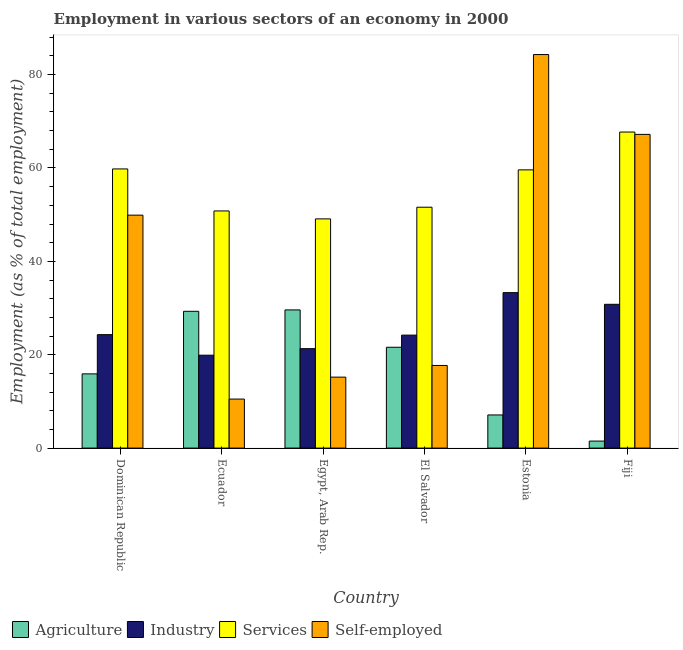How many groups of bars are there?
Ensure brevity in your answer.  6. Are the number of bars per tick equal to the number of legend labels?
Your answer should be very brief. Yes. How many bars are there on the 3rd tick from the left?
Offer a terse response. 4. What is the label of the 5th group of bars from the left?
Ensure brevity in your answer.  Estonia. What is the percentage of workers in industry in Ecuador?
Provide a succinct answer. 19.9. Across all countries, what is the maximum percentage of self employed workers?
Offer a very short reply. 84.3. Across all countries, what is the minimum percentage of workers in industry?
Give a very brief answer. 19.9. In which country was the percentage of self employed workers maximum?
Offer a terse response. Estonia. In which country was the percentage of workers in industry minimum?
Keep it short and to the point. Ecuador. What is the total percentage of workers in agriculture in the graph?
Provide a short and direct response. 105. What is the difference between the percentage of workers in industry in Egypt, Arab Rep. and that in El Salvador?
Make the answer very short. -2.9. What is the difference between the percentage of self employed workers in Fiji and the percentage of workers in industry in El Salvador?
Offer a very short reply. 43. What is the average percentage of self employed workers per country?
Give a very brief answer. 40.8. What is the difference between the percentage of workers in agriculture and percentage of self employed workers in El Salvador?
Ensure brevity in your answer.  3.9. In how many countries, is the percentage of self employed workers greater than 20 %?
Your response must be concise. 3. What is the ratio of the percentage of workers in agriculture in El Salvador to that in Estonia?
Offer a very short reply. 3.04. Is the difference between the percentage of workers in industry in Estonia and Fiji greater than the difference between the percentage of self employed workers in Estonia and Fiji?
Keep it short and to the point. No. What is the difference between the highest and the second highest percentage of workers in services?
Provide a succinct answer. 7.9. What is the difference between the highest and the lowest percentage of self employed workers?
Your response must be concise. 73.8. In how many countries, is the percentage of workers in services greater than the average percentage of workers in services taken over all countries?
Provide a succinct answer. 3. Is it the case that in every country, the sum of the percentage of self employed workers and percentage of workers in services is greater than the sum of percentage of workers in agriculture and percentage of workers in industry?
Provide a short and direct response. No. What does the 3rd bar from the left in Fiji represents?
Your answer should be very brief. Services. What does the 4th bar from the right in El Salvador represents?
Offer a terse response. Agriculture. How many countries are there in the graph?
Offer a very short reply. 6. Are the values on the major ticks of Y-axis written in scientific E-notation?
Your response must be concise. No. Does the graph contain any zero values?
Your response must be concise. No. Does the graph contain grids?
Offer a terse response. No. How are the legend labels stacked?
Your answer should be compact. Horizontal. What is the title of the graph?
Provide a succinct answer. Employment in various sectors of an economy in 2000. What is the label or title of the Y-axis?
Offer a terse response. Employment (as % of total employment). What is the Employment (as % of total employment) of Agriculture in Dominican Republic?
Offer a very short reply. 15.9. What is the Employment (as % of total employment) in Industry in Dominican Republic?
Your response must be concise. 24.3. What is the Employment (as % of total employment) in Services in Dominican Republic?
Offer a very short reply. 59.8. What is the Employment (as % of total employment) in Self-employed in Dominican Republic?
Provide a short and direct response. 49.9. What is the Employment (as % of total employment) of Agriculture in Ecuador?
Give a very brief answer. 29.3. What is the Employment (as % of total employment) of Industry in Ecuador?
Offer a terse response. 19.9. What is the Employment (as % of total employment) in Services in Ecuador?
Provide a succinct answer. 50.8. What is the Employment (as % of total employment) in Self-employed in Ecuador?
Offer a very short reply. 10.5. What is the Employment (as % of total employment) in Agriculture in Egypt, Arab Rep.?
Keep it short and to the point. 29.6. What is the Employment (as % of total employment) in Industry in Egypt, Arab Rep.?
Ensure brevity in your answer.  21.3. What is the Employment (as % of total employment) of Services in Egypt, Arab Rep.?
Offer a terse response. 49.1. What is the Employment (as % of total employment) of Self-employed in Egypt, Arab Rep.?
Keep it short and to the point. 15.2. What is the Employment (as % of total employment) in Agriculture in El Salvador?
Make the answer very short. 21.6. What is the Employment (as % of total employment) in Industry in El Salvador?
Your answer should be very brief. 24.2. What is the Employment (as % of total employment) in Services in El Salvador?
Your response must be concise. 51.6. What is the Employment (as % of total employment) of Self-employed in El Salvador?
Ensure brevity in your answer.  17.7. What is the Employment (as % of total employment) in Agriculture in Estonia?
Your response must be concise. 7.1. What is the Employment (as % of total employment) in Industry in Estonia?
Your response must be concise. 33.3. What is the Employment (as % of total employment) of Services in Estonia?
Your answer should be compact. 59.6. What is the Employment (as % of total employment) of Self-employed in Estonia?
Offer a terse response. 84.3. What is the Employment (as % of total employment) in Agriculture in Fiji?
Ensure brevity in your answer.  1.5. What is the Employment (as % of total employment) in Industry in Fiji?
Offer a very short reply. 30.8. What is the Employment (as % of total employment) in Services in Fiji?
Offer a very short reply. 67.7. What is the Employment (as % of total employment) of Self-employed in Fiji?
Keep it short and to the point. 67.2. Across all countries, what is the maximum Employment (as % of total employment) of Agriculture?
Your answer should be very brief. 29.6. Across all countries, what is the maximum Employment (as % of total employment) in Industry?
Your answer should be compact. 33.3. Across all countries, what is the maximum Employment (as % of total employment) of Services?
Your answer should be compact. 67.7. Across all countries, what is the maximum Employment (as % of total employment) in Self-employed?
Your answer should be very brief. 84.3. Across all countries, what is the minimum Employment (as % of total employment) of Industry?
Make the answer very short. 19.9. Across all countries, what is the minimum Employment (as % of total employment) of Services?
Your answer should be compact. 49.1. What is the total Employment (as % of total employment) of Agriculture in the graph?
Keep it short and to the point. 105. What is the total Employment (as % of total employment) in Industry in the graph?
Provide a short and direct response. 153.8. What is the total Employment (as % of total employment) in Services in the graph?
Your answer should be very brief. 338.6. What is the total Employment (as % of total employment) in Self-employed in the graph?
Ensure brevity in your answer.  244.8. What is the difference between the Employment (as % of total employment) of Agriculture in Dominican Republic and that in Ecuador?
Make the answer very short. -13.4. What is the difference between the Employment (as % of total employment) in Self-employed in Dominican Republic and that in Ecuador?
Offer a very short reply. 39.4. What is the difference between the Employment (as % of total employment) in Agriculture in Dominican Republic and that in Egypt, Arab Rep.?
Keep it short and to the point. -13.7. What is the difference between the Employment (as % of total employment) in Self-employed in Dominican Republic and that in Egypt, Arab Rep.?
Ensure brevity in your answer.  34.7. What is the difference between the Employment (as % of total employment) in Agriculture in Dominican Republic and that in El Salvador?
Your response must be concise. -5.7. What is the difference between the Employment (as % of total employment) in Industry in Dominican Republic and that in El Salvador?
Provide a succinct answer. 0.1. What is the difference between the Employment (as % of total employment) in Self-employed in Dominican Republic and that in El Salvador?
Your response must be concise. 32.2. What is the difference between the Employment (as % of total employment) of Agriculture in Dominican Republic and that in Estonia?
Provide a short and direct response. 8.8. What is the difference between the Employment (as % of total employment) of Self-employed in Dominican Republic and that in Estonia?
Your response must be concise. -34.4. What is the difference between the Employment (as % of total employment) in Agriculture in Dominican Republic and that in Fiji?
Provide a succinct answer. 14.4. What is the difference between the Employment (as % of total employment) of Self-employed in Dominican Republic and that in Fiji?
Your answer should be compact. -17.3. What is the difference between the Employment (as % of total employment) in Agriculture in Ecuador and that in Egypt, Arab Rep.?
Your response must be concise. -0.3. What is the difference between the Employment (as % of total employment) in Industry in Ecuador and that in Egypt, Arab Rep.?
Your response must be concise. -1.4. What is the difference between the Employment (as % of total employment) in Services in Ecuador and that in Egypt, Arab Rep.?
Ensure brevity in your answer.  1.7. What is the difference between the Employment (as % of total employment) of Self-employed in Ecuador and that in Egypt, Arab Rep.?
Ensure brevity in your answer.  -4.7. What is the difference between the Employment (as % of total employment) of Agriculture in Ecuador and that in El Salvador?
Your response must be concise. 7.7. What is the difference between the Employment (as % of total employment) in Industry in Ecuador and that in El Salvador?
Your response must be concise. -4.3. What is the difference between the Employment (as % of total employment) of Services in Ecuador and that in El Salvador?
Make the answer very short. -0.8. What is the difference between the Employment (as % of total employment) in Agriculture in Ecuador and that in Estonia?
Make the answer very short. 22.2. What is the difference between the Employment (as % of total employment) of Services in Ecuador and that in Estonia?
Provide a succinct answer. -8.8. What is the difference between the Employment (as % of total employment) in Self-employed in Ecuador and that in Estonia?
Offer a very short reply. -73.8. What is the difference between the Employment (as % of total employment) of Agriculture in Ecuador and that in Fiji?
Offer a very short reply. 27.8. What is the difference between the Employment (as % of total employment) in Industry in Ecuador and that in Fiji?
Offer a terse response. -10.9. What is the difference between the Employment (as % of total employment) in Services in Ecuador and that in Fiji?
Make the answer very short. -16.9. What is the difference between the Employment (as % of total employment) of Self-employed in Ecuador and that in Fiji?
Your answer should be compact. -56.7. What is the difference between the Employment (as % of total employment) in Agriculture in Egypt, Arab Rep. and that in El Salvador?
Your response must be concise. 8. What is the difference between the Employment (as % of total employment) of Industry in Egypt, Arab Rep. and that in El Salvador?
Provide a succinct answer. -2.9. What is the difference between the Employment (as % of total employment) in Self-employed in Egypt, Arab Rep. and that in Estonia?
Your answer should be very brief. -69.1. What is the difference between the Employment (as % of total employment) in Agriculture in Egypt, Arab Rep. and that in Fiji?
Your answer should be very brief. 28.1. What is the difference between the Employment (as % of total employment) of Industry in Egypt, Arab Rep. and that in Fiji?
Give a very brief answer. -9.5. What is the difference between the Employment (as % of total employment) in Services in Egypt, Arab Rep. and that in Fiji?
Offer a very short reply. -18.6. What is the difference between the Employment (as % of total employment) in Self-employed in Egypt, Arab Rep. and that in Fiji?
Make the answer very short. -52. What is the difference between the Employment (as % of total employment) of Industry in El Salvador and that in Estonia?
Provide a short and direct response. -9.1. What is the difference between the Employment (as % of total employment) of Self-employed in El Salvador and that in Estonia?
Provide a short and direct response. -66.6. What is the difference between the Employment (as % of total employment) of Agriculture in El Salvador and that in Fiji?
Keep it short and to the point. 20.1. What is the difference between the Employment (as % of total employment) of Services in El Salvador and that in Fiji?
Offer a very short reply. -16.1. What is the difference between the Employment (as % of total employment) in Self-employed in El Salvador and that in Fiji?
Ensure brevity in your answer.  -49.5. What is the difference between the Employment (as % of total employment) of Industry in Estonia and that in Fiji?
Give a very brief answer. 2.5. What is the difference between the Employment (as % of total employment) of Services in Estonia and that in Fiji?
Keep it short and to the point. -8.1. What is the difference between the Employment (as % of total employment) of Agriculture in Dominican Republic and the Employment (as % of total employment) of Services in Ecuador?
Give a very brief answer. -34.9. What is the difference between the Employment (as % of total employment) in Industry in Dominican Republic and the Employment (as % of total employment) in Services in Ecuador?
Offer a very short reply. -26.5. What is the difference between the Employment (as % of total employment) in Services in Dominican Republic and the Employment (as % of total employment) in Self-employed in Ecuador?
Provide a short and direct response. 49.3. What is the difference between the Employment (as % of total employment) of Agriculture in Dominican Republic and the Employment (as % of total employment) of Industry in Egypt, Arab Rep.?
Your answer should be very brief. -5.4. What is the difference between the Employment (as % of total employment) in Agriculture in Dominican Republic and the Employment (as % of total employment) in Services in Egypt, Arab Rep.?
Your response must be concise. -33.2. What is the difference between the Employment (as % of total employment) of Agriculture in Dominican Republic and the Employment (as % of total employment) of Self-employed in Egypt, Arab Rep.?
Your response must be concise. 0.7. What is the difference between the Employment (as % of total employment) in Industry in Dominican Republic and the Employment (as % of total employment) in Services in Egypt, Arab Rep.?
Ensure brevity in your answer.  -24.8. What is the difference between the Employment (as % of total employment) in Services in Dominican Republic and the Employment (as % of total employment) in Self-employed in Egypt, Arab Rep.?
Your response must be concise. 44.6. What is the difference between the Employment (as % of total employment) in Agriculture in Dominican Republic and the Employment (as % of total employment) in Services in El Salvador?
Ensure brevity in your answer.  -35.7. What is the difference between the Employment (as % of total employment) of Industry in Dominican Republic and the Employment (as % of total employment) of Services in El Salvador?
Offer a terse response. -27.3. What is the difference between the Employment (as % of total employment) of Industry in Dominican Republic and the Employment (as % of total employment) of Self-employed in El Salvador?
Make the answer very short. 6.6. What is the difference between the Employment (as % of total employment) in Services in Dominican Republic and the Employment (as % of total employment) in Self-employed in El Salvador?
Give a very brief answer. 42.1. What is the difference between the Employment (as % of total employment) in Agriculture in Dominican Republic and the Employment (as % of total employment) in Industry in Estonia?
Provide a succinct answer. -17.4. What is the difference between the Employment (as % of total employment) of Agriculture in Dominican Republic and the Employment (as % of total employment) of Services in Estonia?
Offer a very short reply. -43.7. What is the difference between the Employment (as % of total employment) in Agriculture in Dominican Republic and the Employment (as % of total employment) in Self-employed in Estonia?
Ensure brevity in your answer.  -68.4. What is the difference between the Employment (as % of total employment) of Industry in Dominican Republic and the Employment (as % of total employment) of Services in Estonia?
Your answer should be very brief. -35.3. What is the difference between the Employment (as % of total employment) of Industry in Dominican Republic and the Employment (as % of total employment) of Self-employed in Estonia?
Provide a succinct answer. -60. What is the difference between the Employment (as % of total employment) of Services in Dominican Republic and the Employment (as % of total employment) of Self-employed in Estonia?
Provide a succinct answer. -24.5. What is the difference between the Employment (as % of total employment) in Agriculture in Dominican Republic and the Employment (as % of total employment) in Industry in Fiji?
Your response must be concise. -14.9. What is the difference between the Employment (as % of total employment) in Agriculture in Dominican Republic and the Employment (as % of total employment) in Services in Fiji?
Keep it short and to the point. -51.8. What is the difference between the Employment (as % of total employment) of Agriculture in Dominican Republic and the Employment (as % of total employment) of Self-employed in Fiji?
Provide a short and direct response. -51.3. What is the difference between the Employment (as % of total employment) in Industry in Dominican Republic and the Employment (as % of total employment) in Services in Fiji?
Keep it short and to the point. -43.4. What is the difference between the Employment (as % of total employment) of Industry in Dominican Republic and the Employment (as % of total employment) of Self-employed in Fiji?
Keep it short and to the point. -42.9. What is the difference between the Employment (as % of total employment) of Agriculture in Ecuador and the Employment (as % of total employment) of Services in Egypt, Arab Rep.?
Your answer should be compact. -19.8. What is the difference between the Employment (as % of total employment) in Industry in Ecuador and the Employment (as % of total employment) in Services in Egypt, Arab Rep.?
Provide a succinct answer. -29.2. What is the difference between the Employment (as % of total employment) in Services in Ecuador and the Employment (as % of total employment) in Self-employed in Egypt, Arab Rep.?
Your answer should be very brief. 35.6. What is the difference between the Employment (as % of total employment) of Agriculture in Ecuador and the Employment (as % of total employment) of Industry in El Salvador?
Give a very brief answer. 5.1. What is the difference between the Employment (as % of total employment) in Agriculture in Ecuador and the Employment (as % of total employment) in Services in El Salvador?
Provide a succinct answer. -22.3. What is the difference between the Employment (as % of total employment) in Industry in Ecuador and the Employment (as % of total employment) in Services in El Salvador?
Offer a terse response. -31.7. What is the difference between the Employment (as % of total employment) in Industry in Ecuador and the Employment (as % of total employment) in Self-employed in El Salvador?
Give a very brief answer. 2.2. What is the difference between the Employment (as % of total employment) of Services in Ecuador and the Employment (as % of total employment) of Self-employed in El Salvador?
Give a very brief answer. 33.1. What is the difference between the Employment (as % of total employment) of Agriculture in Ecuador and the Employment (as % of total employment) of Services in Estonia?
Provide a succinct answer. -30.3. What is the difference between the Employment (as % of total employment) in Agriculture in Ecuador and the Employment (as % of total employment) in Self-employed in Estonia?
Provide a succinct answer. -55. What is the difference between the Employment (as % of total employment) in Industry in Ecuador and the Employment (as % of total employment) in Services in Estonia?
Offer a terse response. -39.7. What is the difference between the Employment (as % of total employment) in Industry in Ecuador and the Employment (as % of total employment) in Self-employed in Estonia?
Your response must be concise. -64.4. What is the difference between the Employment (as % of total employment) of Services in Ecuador and the Employment (as % of total employment) of Self-employed in Estonia?
Keep it short and to the point. -33.5. What is the difference between the Employment (as % of total employment) of Agriculture in Ecuador and the Employment (as % of total employment) of Services in Fiji?
Your answer should be compact. -38.4. What is the difference between the Employment (as % of total employment) in Agriculture in Ecuador and the Employment (as % of total employment) in Self-employed in Fiji?
Your response must be concise. -37.9. What is the difference between the Employment (as % of total employment) in Industry in Ecuador and the Employment (as % of total employment) in Services in Fiji?
Your answer should be very brief. -47.8. What is the difference between the Employment (as % of total employment) in Industry in Ecuador and the Employment (as % of total employment) in Self-employed in Fiji?
Keep it short and to the point. -47.3. What is the difference between the Employment (as % of total employment) in Services in Ecuador and the Employment (as % of total employment) in Self-employed in Fiji?
Make the answer very short. -16.4. What is the difference between the Employment (as % of total employment) in Agriculture in Egypt, Arab Rep. and the Employment (as % of total employment) in Industry in El Salvador?
Ensure brevity in your answer.  5.4. What is the difference between the Employment (as % of total employment) in Industry in Egypt, Arab Rep. and the Employment (as % of total employment) in Services in El Salvador?
Keep it short and to the point. -30.3. What is the difference between the Employment (as % of total employment) of Services in Egypt, Arab Rep. and the Employment (as % of total employment) of Self-employed in El Salvador?
Your answer should be very brief. 31.4. What is the difference between the Employment (as % of total employment) in Agriculture in Egypt, Arab Rep. and the Employment (as % of total employment) in Services in Estonia?
Provide a short and direct response. -30. What is the difference between the Employment (as % of total employment) of Agriculture in Egypt, Arab Rep. and the Employment (as % of total employment) of Self-employed in Estonia?
Your answer should be very brief. -54.7. What is the difference between the Employment (as % of total employment) of Industry in Egypt, Arab Rep. and the Employment (as % of total employment) of Services in Estonia?
Make the answer very short. -38.3. What is the difference between the Employment (as % of total employment) of Industry in Egypt, Arab Rep. and the Employment (as % of total employment) of Self-employed in Estonia?
Your answer should be very brief. -63. What is the difference between the Employment (as % of total employment) in Services in Egypt, Arab Rep. and the Employment (as % of total employment) in Self-employed in Estonia?
Make the answer very short. -35.2. What is the difference between the Employment (as % of total employment) of Agriculture in Egypt, Arab Rep. and the Employment (as % of total employment) of Services in Fiji?
Provide a short and direct response. -38.1. What is the difference between the Employment (as % of total employment) of Agriculture in Egypt, Arab Rep. and the Employment (as % of total employment) of Self-employed in Fiji?
Your response must be concise. -37.6. What is the difference between the Employment (as % of total employment) of Industry in Egypt, Arab Rep. and the Employment (as % of total employment) of Services in Fiji?
Ensure brevity in your answer.  -46.4. What is the difference between the Employment (as % of total employment) in Industry in Egypt, Arab Rep. and the Employment (as % of total employment) in Self-employed in Fiji?
Ensure brevity in your answer.  -45.9. What is the difference between the Employment (as % of total employment) of Services in Egypt, Arab Rep. and the Employment (as % of total employment) of Self-employed in Fiji?
Ensure brevity in your answer.  -18.1. What is the difference between the Employment (as % of total employment) of Agriculture in El Salvador and the Employment (as % of total employment) of Services in Estonia?
Your answer should be compact. -38. What is the difference between the Employment (as % of total employment) in Agriculture in El Salvador and the Employment (as % of total employment) in Self-employed in Estonia?
Make the answer very short. -62.7. What is the difference between the Employment (as % of total employment) in Industry in El Salvador and the Employment (as % of total employment) in Services in Estonia?
Ensure brevity in your answer.  -35.4. What is the difference between the Employment (as % of total employment) in Industry in El Salvador and the Employment (as % of total employment) in Self-employed in Estonia?
Your response must be concise. -60.1. What is the difference between the Employment (as % of total employment) in Services in El Salvador and the Employment (as % of total employment) in Self-employed in Estonia?
Your response must be concise. -32.7. What is the difference between the Employment (as % of total employment) of Agriculture in El Salvador and the Employment (as % of total employment) of Industry in Fiji?
Your answer should be very brief. -9.2. What is the difference between the Employment (as % of total employment) of Agriculture in El Salvador and the Employment (as % of total employment) of Services in Fiji?
Offer a very short reply. -46.1. What is the difference between the Employment (as % of total employment) of Agriculture in El Salvador and the Employment (as % of total employment) of Self-employed in Fiji?
Your response must be concise. -45.6. What is the difference between the Employment (as % of total employment) of Industry in El Salvador and the Employment (as % of total employment) of Services in Fiji?
Offer a terse response. -43.5. What is the difference between the Employment (as % of total employment) of Industry in El Salvador and the Employment (as % of total employment) of Self-employed in Fiji?
Give a very brief answer. -43. What is the difference between the Employment (as % of total employment) in Services in El Salvador and the Employment (as % of total employment) in Self-employed in Fiji?
Keep it short and to the point. -15.6. What is the difference between the Employment (as % of total employment) of Agriculture in Estonia and the Employment (as % of total employment) of Industry in Fiji?
Your answer should be very brief. -23.7. What is the difference between the Employment (as % of total employment) in Agriculture in Estonia and the Employment (as % of total employment) in Services in Fiji?
Make the answer very short. -60.6. What is the difference between the Employment (as % of total employment) of Agriculture in Estonia and the Employment (as % of total employment) of Self-employed in Fiji?
Offer a terse response. -60.1. What is the difference between the Employment (as % of total employment) of Industry in Estonia and the Employment (as % of total employment) of Services in Fiji?
Give a very brief answer. -34.4. What is the difference between the Employment (as % of total employment) of Industry in Estonia and the Employment (as % of total employment) of Self-employed in Fiji?
Your answer should be very brief. -33.9. What is the average Employment (as % of total employment) in Industry per country?
Provide a short and direct response. 25.63. What is the average Employment (as % of total employment) in Services per country?
Make the answer very short. 56.43. What is the average Employment (as % of total employment) of Self-employed per country?
Ensure brevity in your answer.  40.8. What is the difference between the Employment (as % of total employment) of Agriculture and Employment (as % of total employment) of Industry in Dominican Republic?
Make the answer very short. -8.4. What is the difference between the Employment (as % of total employment) in Agriculture and Employment (as % of total employment) in Services in Dominican Republic?
Your answer should be compact. -43.9. What is the difference between the Employment (as % of total employment) in Agriculture and Employment (as % of total employment) in Self-employed in Dominican Republic?
Ensure brevity in your answer.  -34. What is the difference between the Employment (as % of total employment) in Industry and Employment (as % of total employment) in Services in Dominican Republic?
Make the answer very short. -35.5. What is the difference between the Employment (as % of total employment) of Industry and Employment (as % of total employment) of Self-employed in Dominican Republic?
Give a very brief answer. -25.6. What is the difference between the Employment (as % of total employment) of Services and Employment (as % of total employment) of Self-employed in Dominican Republic?
Your answer should be compact. 9.9. What is the difference between the Employment (as % of total employment) in Agriculture and Employment (as % of total employment) in Services in Ecuador?
Provide a short and direct response. -21.5. What is the difference between the Employment (as % of total employment) of Agriculture and Employment (as % of total employment) of Self-employed in Ecuador?
Give a very brief answer. 18.8. What is the difference between the Employment (as % of total employment) of Industry and Employment (as % of total employment) of Services in Ecuador?
Provide a short and direct response. -30.9. What is the difference between the Employment (as % of total employment) in Services and Employment (as % of total employment) in Self-employed in Ecuador?
Your answer should be very brief. 40.3. What is the difference between the Employment (as % of total employment) in Agriculture and Employment (as % of total employment) in Industry in Egypt, Arab Rep.?
Your answer should be compact. 8.3. What is the difference between the Employment (as % of total employment) of Agriculture and Employment (as % of total employment) of Services in Egypt, Arab Rep.?
Keep it short and to the point. -19.5. What is the difference between the Employment (as % of total employment) in Agriculture and Employment (as % of total employment) in Self-employed in Egypt, Arab Rep.?
Ensure brevity in your answer.  14.4. What is the difference between the Employment (as % of total employment) in Industry and Employment (as % of total employment) in Services in Egypt, Arab Rep.?
Ensure brevity in your answer.  -27.8. What is the difference between the Employment (as % of total employment) of Services and Employment (as % of total employment) of Self-employed in Egypt, Arab Rep.?
Make the answer very short. 33.9. What is the difference between the Employment (as % of total employment) of Agriculture and Employment (as % of total employment) of Services in El Salvador?
Your answer should be very brief. -30. What is the difference between the Employment (as % of total employment) of Industry and Employment (as % of total employment) of Services in El Salvador?
Provide a succinct answer. -27.4. What is the difference between the Employment (as % of total employment) of Services and Employment (as % of total employment) of Self-employed in El Salvador?
Make the answer very short. 33.9. What is the difference between the Employment (as % of total employment) of Agriculture and Employment (as % of total employment) of Industry in Estonia?
Keep it short and to the point. -26.2. What is the difference between the Employment (as % of total employment) of Agriculture and Employment (as % of total employment) of Services in Estonia?
Provide a succinct answer. -52.5. What is the difference between the Employment (as % of total employment) in Agriculture and Employment (as % of total employment) in Self-employed in Estonia?
Offer a very short reply. -77.2. What is the difference between the Employment (as % of total employment) in Industry and Employment (as % of total employment) in Services in Estonia?
Your answer should be very brief. -26.3. What is the difference between the Employment (as % of total employment) in Industry and Employment (as % of total employment) in Self-employed in Estonia?
Provide a succinct answer. -51. What is the difference between the Employment (as % of total employment) of Services and Employment (as % of total employment) of Self-employed in Estonia?
Keep it short and to the point. -24.7. What is the difference between the Employment (as % of total employment) of Agriculture and Employment (as % of total employment) of Industry in Fiji?
Offer a terse response. -29.3. What is the difference between the Employment (as % of total employment) in Agriculture and Employment (as % of total employment) in Services in Fiji?
Provide a short and direct response. -66.2. What is the difference between the Employment (as % of total employment) in Agriculture and Employment (as % of total employment) in Self-employed in Fiji?
Your response must be concise. -65.7. What is the difference between the Employment (as % of total employment) in Industry and Employment (as % of total employment) in Services in Fiji?
Ensure brevity in your answer.  -36.9. What is the difference between the Employment (as % of total employment) in Industry and Employment (as % of total employment) in Self-employed in Fiji?
Make the answer very short. -36.4. What is the ratio of the Employment (as % of total employment) in Agriculture in Dominican Republic to that in Ecuador?
Provide a short and direct response. 0.54. What is the ratio of the Employment (as % of total employment) of Industry in Dominican Republic to that in Ecuador?
Give a very brief answer. 1.22. What is the ratio of the Employment (as % of total employment) of Services in Dominican Republic to that in Ecuador?
Ensure brevity in your answer.  1.18. What is the ratio of the Employment (as % of total employment) in Self-employed in Dominican Republic to that in Ecuador?
Make the answer very short. 4.75. What is the ratio of the Employment (as % of total employment) in Agriculture in Dominican Republic to that in Egypt, Arab Rep.?
Your response must be concise. 0.54. What is the ratio of the Employment (as % of total employment) in Industry in Dominican Republic to that in Egypt, Arab Rep.?
Make the answer very short. 1.14. What is the ratio of the Employment (as % of total employment) in Services in Dominican Republic to that in Egypt, Arab Rep.?
Offer a terse response. 1.22. What is the ratio of the Employment (as % of total employment) of Self-employed in Dominican Republic to that in Egypt, Arab Rep.?
Provide a short and direct response. 3.28. What is the ratio of the Employment (as % of total employment) in Agriculture in Dominican Republic to that in El Salvador?
Make the answer very short. 0.74. What is the ratio of the Employment (as % of total employment) of Industry in Dominican Republic to that in El Salvador?
Offer a very short reply. 1. What is the ratio of the Employment (as % of total employment) in Services in Dominican Republic to that in El Salvador?
Offer a terse response. 1.16. What is the ratio of the Employment (as % of total employment) of Self-employed in Dominican Republic to that in El Salvador?
Ensure brevity in your answer.  2.82. What is the ratio of the Employment (as % of total employment) in Agriculture in Dominican Republic to that in Estonia?
Offer a terse response. 2.24. What is the ratio of the Employment (as % of total employment) in Industry in Dominican Republic to that in Estonia?
Your answer should be compact. 0.73. What is the ratio of the Employment (as % of total employment) in Services in Dominican Republic to that in Estonia?
Your answer should be compact. 1. What is the ratio of the Employment (as % of total employment) of Self-employed in Dominican Republic to that in Estonia?
Your answer should be compact. 0.59. What is the ratio of the Employment (as % of total employment) in Industry in Dominican Republic to that in Fiji?
Ensure brevity in your answer.  0.79. What is the ratio of the Employment (as % of total employment) of Services in Dominican Republic to that in Fiji?
Your answer should be compact. 0.88. What is the ratio of the Employment (as % of total employment) in Self-employed in Dominican Republic to that in Fiji?
Provide a short and direct response. 0.74. What is the ratio of the Employment (as % of total employment) of Industry in Ecuador to that in Egypt, Arab Rep.?
Keep it short and to the point. 0.93. What is the ratio of the Employment (as % of total employment) in Services in Ecuador to that in Egypt, Arab Rep.?
Offer a very short reply. 1.03. What is the ratio of the Employment (as % of total employment) of Self-employed in Ecuador to that in Egypt, Arab Rep.?
Your response must be concise. 0.69. What is the ratio of the Employment (as % of total employment) of Agriculture in Ecuador to that in El Salvador?
Offer a very short reply. 1.36. What is the ratio of the Employment (as % of total employment) of Industry in Ecuador to that in El Salvador?
Keep it short and to the point. 0.82. What is the ratio of the Employment (as % of total employment) of Services in Ecuador to that in El Salvador?
Provide a succinct answer. 0.98. What is the ratio of the Employment (as % of total employment) of Self-employed in Ecuador to that in El Salvador?
Provide a succinct answer. 0.59. What is the ratio of the Employment (as % of total employment) of Agriculture in Ecuador to that in Estonia?
Provide a short and direct response. 4.13. What is the ratio of the Employment (as % of total employment) in Industry in Ecuador to that in Estonia?
Ensure brevity in your answer.  0.6. What is the ratio of the Employment (as % of total employment) in Services in Ecuador to that in Estonia?
Give a very brief answer. 0.85. What is the ratio of the Employment (as % of total employment) of Self-employed in Ecuador to that in Estonia?
Ensure brevity in your answer.  0.12. What is the ratio of the Employment (as % of total employment) in Agriculture in Ecuador to that in Fiji?
Keep it short and to the point. 19.53. What is the ratio of the Employment (as % of total employment) of Industry in Ecuador to that in Fiji?
Your answer should be compact. 0.65. What is the ratio of the Employment (as % of total employment) of Services in Ecuador to that in Fiji?
Your answer should be very brief. 0.75. What is the ratio of the Employment (as % of total employment) of Self-employed in Ecuador to that in Fiji?
Offer a very short reply. 0.16. What is the ratio of the Employment (as % of total employment) of Agriculture in Egypt, Arab Rep. to that in El Salvador?
Ensure brevity in your answer.  1.37. What is the ratio of the Employment (as % of total employment) in Industry in Egypt, Arab Rep. to that in El Salvador?
Make the answer very short. 0.88. What is the ratio of the Employment (as % of total employment) in Services in Egypt, Arab Rep. to that in El Salvador?
Your answer should be compact. 0.95. What is the ratio of the Employment (as % of total employment) in Self-employed in Egypt, Arab Rep. to that in El Salvador?
Make the answer very short. 0.86. What is the ratio of the Employment (as % of total employment) in Agriculture in Egypt, Arab Rep. to that in Estonia?
Your answer should be very brief. 4.17. What is the ratio of the Employment (as % of total employment) of Industry in Egypt, Arab Rep. to that in Estonia?
Make the answer very short. 0.64. What is the ratio of the Employment (as % of total employment) in Services in Egypt, Arab Rep. to that in Estonia?
Ensure brevity in your answer.  0.82. What is the ratio of the Employment (as % of total employment) of Self-employed in Egypt, Arab Rep. to that in Estonia?
Make the answer very short. 0.18. What is the ratio of the Employment (as % of total employment) of Agriculture in Egypt, Arab Rep. to that in Fiji?
Provide a short and direct response. 19.73. What is the ratio of the Employment (as % of total employment) of Industry in Egypt, Arab Rep. to that in Fiji?
Your response must be concise. 0.69. What is the ratio of the Employment (as % of total employment) of Services in Egypt, Arab Rep. to that in Fiji?
Provide a short and direct response. 0.73. What is the ratio of the Employment (as % of total employment) of Self-employed in Egypt, Arab Rep. to that in Fiji?
Your response must be concise. 0.23. What is the ratio of the Employment (as % of total employment) of Agriculture in El Salvador to that in Estonia?
Your response must be concise. 3.04. What is the ratio of the Employment (as % of total employment) in Industry in El Salvador to that in Estonia?
Provide a short and direct response. 0.73. What is the ratio of the Employment (as % of total employment) in Services in El Salvador to that in Estonia?
Your response must be concise. 0.87. What is the ratio of the Employment (as % of total employment) of Self-employed in El Salvador to that in Estonia?
Provide a short and direct response. 0.21. What is the ratio of the Employment (as % of total employment) of Agriculture in El Salvador to that in Fiji?
Keep it short and to the point. 14.4. What is the ratio of the Employment (as % of total employment) in Industry in El Salvador to that in Fiji?
Provide a short and direct response. 0.79. What is the ratio of the Employment (as % of total employment) in Services in El Salvador to that in Fiji?
Your answer should be compact. 0.76. What is the ratio of the Employment (as % of total employment) in Self-employed in El Salvador to that in Fiji?
Give a very brief answer. 0.26. What is the ratio of the Employment (as % of total employment) in Agriculture in Estonia to that in Fiji?
Provide a succinct answer. 4.73. What is the ratio of the Employment (as % of total employment) in Industry in Estonia to that in Fiji?
Offer a terse response. 1.08. What is the ratio of the Employment (as % of total employment) in Services in Estonia to that in Fiji?
Your response must be concise. 0.88. What is the ratio of the Employment (as % of total employment) in Self-employed in Estonia to that in Fiji?
Provide a succinct answer. 1.25. What is the difference between the highest and the second highest Employment (as % of total employment) in Services?
Give a very brief answer. 7.9. What is the difference between the highest and the second highest Employment (as % of total employment) of Self-employed?
Your answer should be very brief. 17.1. What is the difference between the highest and the lowest Employment (as % of total employment) of Agriculture?
Give a very brief answer. 28.1. What is the difference between the highest and the lowest Employment (as % of total employment) of Industry?
Your response must be concise. 13.4. What is the difference between the highest and the lowest Employment (as % of total employment) in Self-employed?
Ensure brevity in your answer.  73.8. 